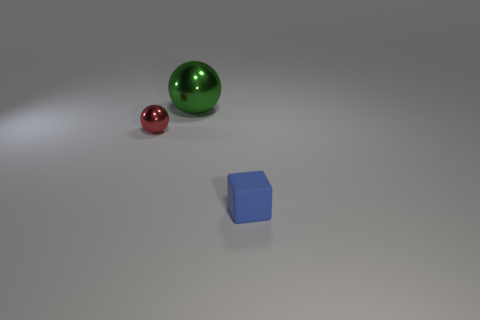Add 1 tiny metal things. How many objects exist? 4 Subtract all red spheres. How many spheres are left? 1 Subtract 2 balls. How many balls are left? 0 Subtract all yellow cubes. Subtract all blue cylinders. How many cubes are left? 1 Subtract all purple balls. How many cyan cubes are left? 0 Subtract all green cylinders. Subtract all blue matte things. How many objects are left? 2 Add 1 green objects. How many green objects are left? 2 Add 3 large green shiny things. How many large green shiny things exist? 4 Subtract 0 blue cylinders. How many objects are left? 3 Subtract all balls. How many objects are left? 1 